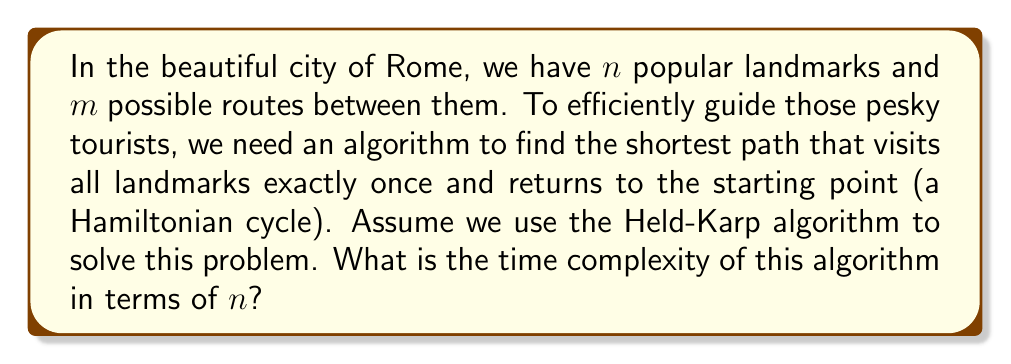Provide a solution to this math problem. Let's analyze the Held-Karp algorithm for solving the Traveling Salesman Problem (TSP) in this context:

1) The Held-Karp algorithm uses dynamic programming to solve the TSP.

2) It considers all possible subsets of landmarks and all possible last landmarks for each subset.

3) For each subset size $k$ from 2 to $n$, it computes:

   $$C(S, j) = \min_{i \in S, i \neq j} \{C(S - \{j\}, i) + d_{ij}\}$$

   where $C(S, j)$ is the cost of the best path visiting all vertices in set $S$ exactly once and ending at vertex $j$, and $d_{ij}$ is the distance from landmark $i$ to $j$.

4) There are $2^n$ possible subsets of $n$ landmarks.

5) For each subset, we consider at most $n$ possible last landmarks.

6) For each of these combinations, we perform a minimization operation over at most $n$ elements.

7) Therefore, the total number of operations is bounded by $O(n^2 \cdot 2^n)$.

8) The space complexity is $O(n \cdot 2^n)$ to store the results of subproblems.

Thus, while this algorithm is much faster than the naive $O(n!)$ approach, it still has exponential time complexity.
Answer: The time complexity of the Held-Karp algorithm for efficiently routing tourists through $n$ landmarks in Rome is $O(n^2 \cdot 2^n)$. 